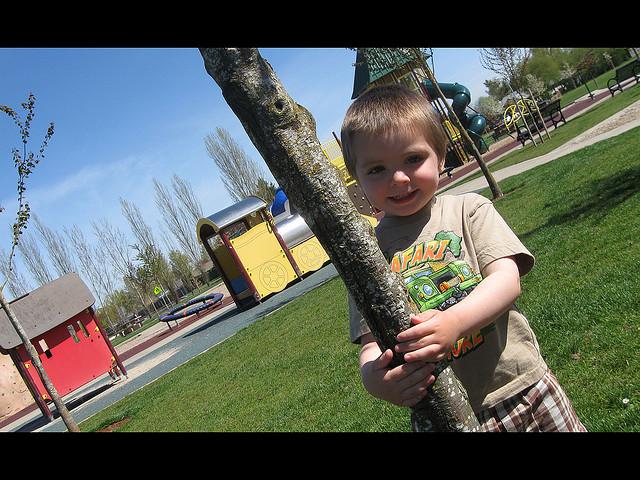What is the word on the child's shirt?
Quick response, please. Safari. What color is the slide?
Be succinct. Green. What is the boy holding on to?
Keep it brief. Tree. 